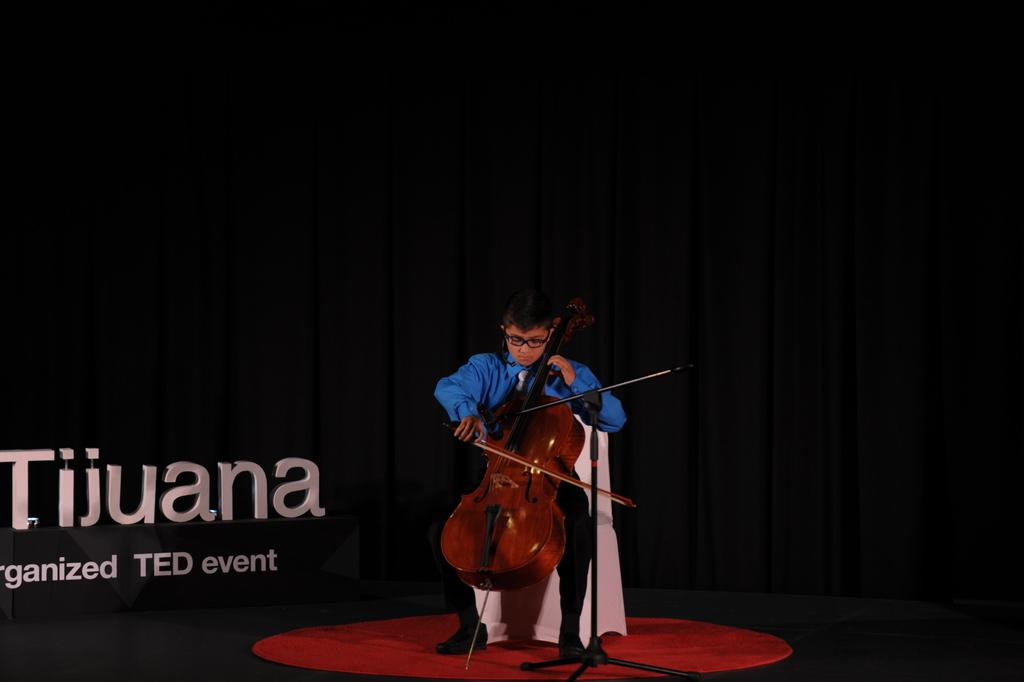What is the main subject of the image? The main subject of the image is a child. What is the child doing in the image? The child is sitting on a chair and playing a violin. Where is the child located in the image? The child is on a stage. What can be seen at the back of the stage? There is a curtain at the back of the stage. What event is mentioned in the image? There is a board mentioning a TED event in the image. What type of thrill can be seen on the child's face while playing the violin? There is no indication of the child's emotions or facial expressions in the image, so it cannot be determined if they are experiencing any thrill. 